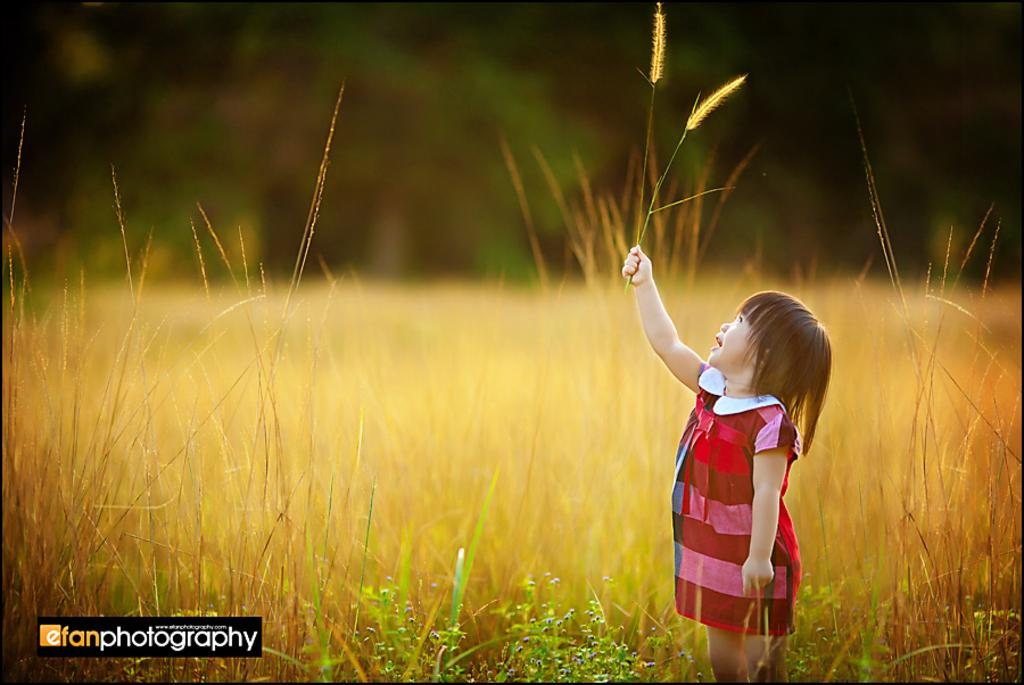What is the main subject of the image? There is a girl standing in the image. What is the girl holding in the image? The girl is holding grass in the image. What type of vegetation can be seen at the bottom of the image? There are plants at the bottom of the image. What type of vegetation is visible in the image besides the plants at the bottom? Grass is visible in the image. Where is the faucet located in the image? There is no faucet present in the image. What type of pleasure can be seen on the girl's face in the image? The image does not show the girl's facial expression, so it cannot be determined if she is experiencing pleasure. 